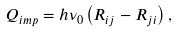Convert formula to latex. <formula><loc_0><loc_0><loc_500><loc_500>Q _ { i m p } = h \nu _ { 0 } \left ( R _ { i j } - R _ { j i } \right ) ,</formula> 